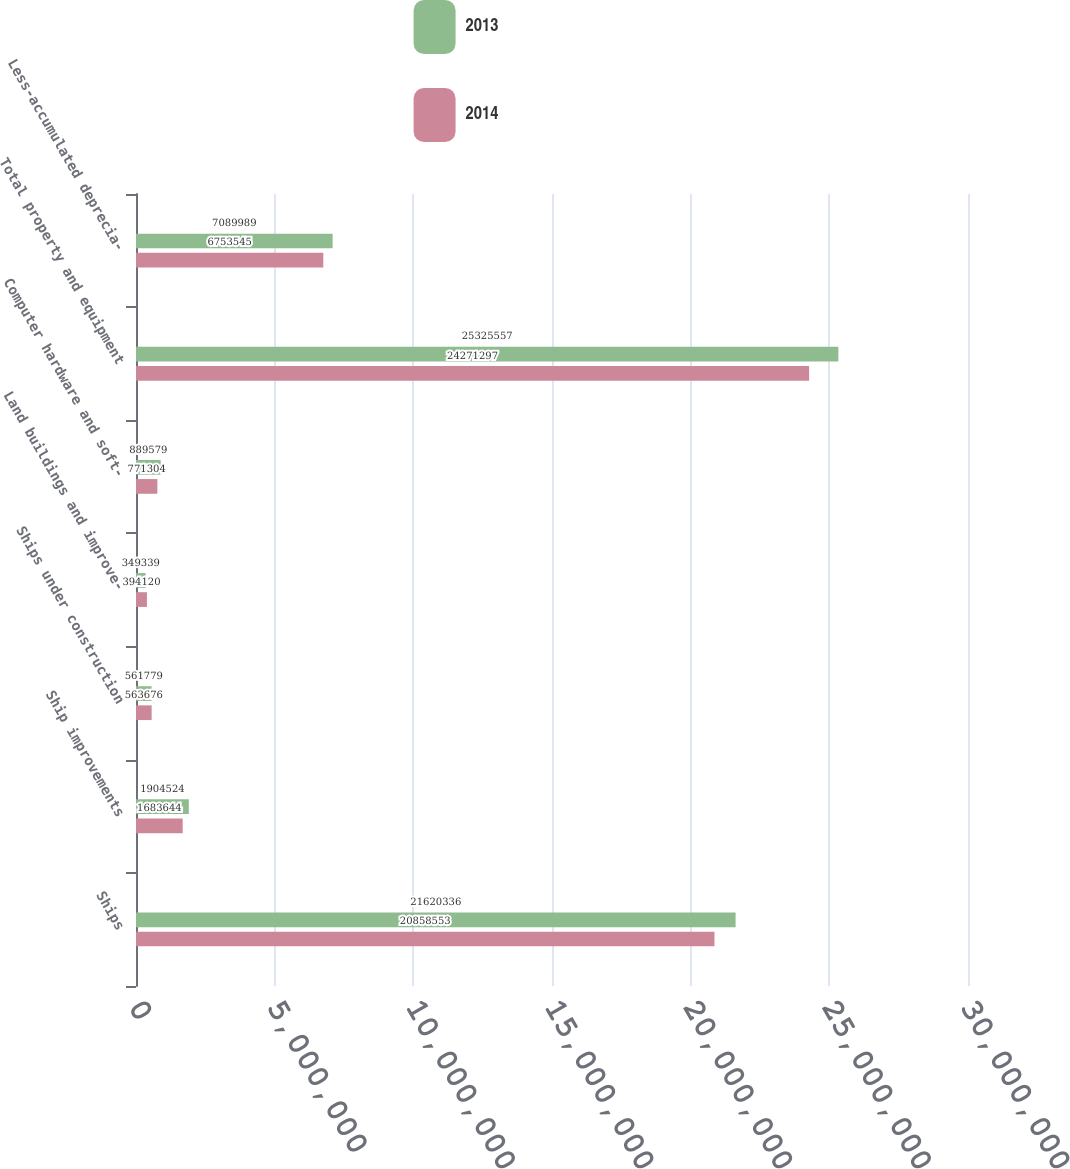<chart> <loc_0><loc_0><loc_500><loc_500><stacked_bar_chart><ecel><fcel>Ships<fcel>Ship improvements<fcel>Ships under construction<fcel>Land buildings and improve-<fcel>Computer hardware and soft-<fcel>Total property and equipment<fcel>Less-accumulated deprecia-<nl><fcel>2013<fcel>2.16203e+07<fcel>1.90452e+06<fcel>561779<fcel>349339<fcel>889579<fcel>2.53256e+07<fcel>7.08999e+06<nl><fcel>2014<fcel>2.08586e+07<fcel>1.68364e+06<fcel>563676<fcel>394120<fcel>771304<fcel>2.42713e+07<fcel>6.75354e+06<nl></chart> 